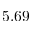Convert formula to latex. <formula><loc_0><loc_0><loc_500><loc_500>5 . 6 9</formula> 